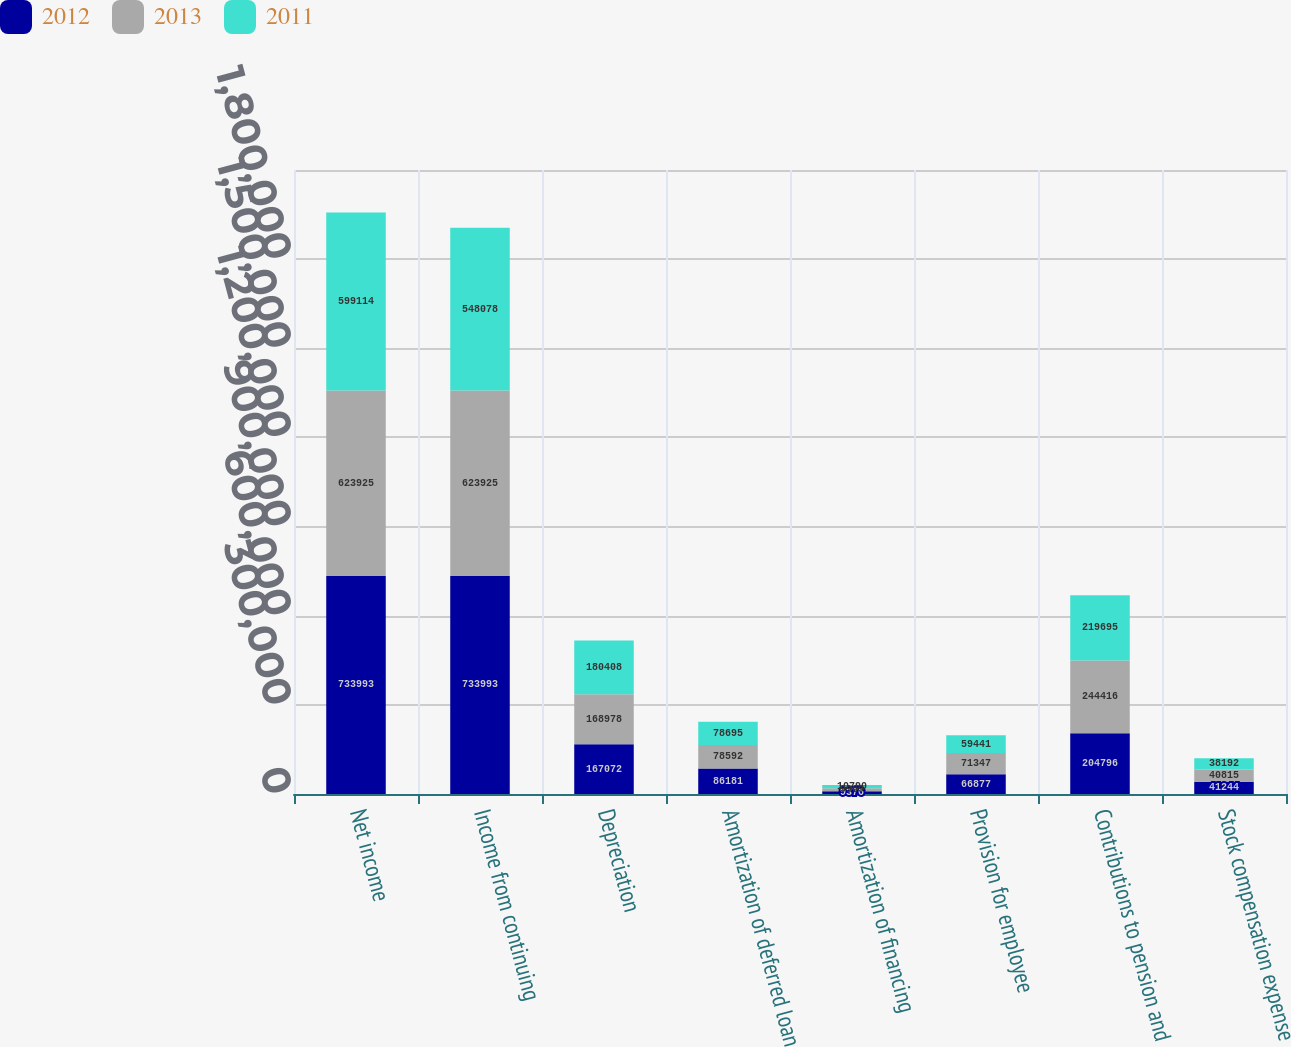Convert chart. <chart><loc_0><loc_0><loc_500><loc_500><stacked_bar_chart><ecel><fcel>Net income<fcel>Income from continuing<fcel>Depreciation<fcel>Amortization of deferred loan<fcel>Amortization of financing<fcel>Provision for employee<fcel>Contributions to pension and<fcel>Stock compensation expense<nl><fcel>2012<fcel>733993<fcel>733993<fcel>167072<fcel>86181<fcel>9376<fcel>66877<fcel>204796<fcel>41244<nl><fcel>2013<fcel>623925<fcel>623925<fcel>168978<fcel>78592<fcel>9969<fcel>71347<fcel>244416<fcel>40815<nl><fcel>2011<fcel>599114<fcel>548078<fcel>180408<fcel>78695<fcel>10790<fcel>59441<fcel>219695<fcel>38192<nl></chart> 